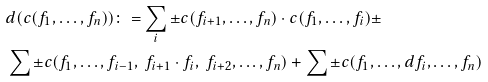<formula> <loc_0><loc_0><loc_500><loc_500>\ & d ( c ( { f _ { 1 } , \dots , f _ { n } } ) ) \colon = \sum _ { i } \pm c ( { f _ { i + 1 } , \dots , f _ { n } } ) \cdot c ( { f _ { 1 } , \dots , f _ { i } } ) \pm \\ & \sum \pm c ( { f _ { 1 } , \dots , f _ { i - 1 } , \ f _ { i + 1 } \cdot f _ { i } , \ f _ { i + 2 } , \dots , f _ { n } } ) + \sum \pm c ( { f _ { 1 } , \dots , d f _ { i } , \dots , f _ { n } } )</formula> 